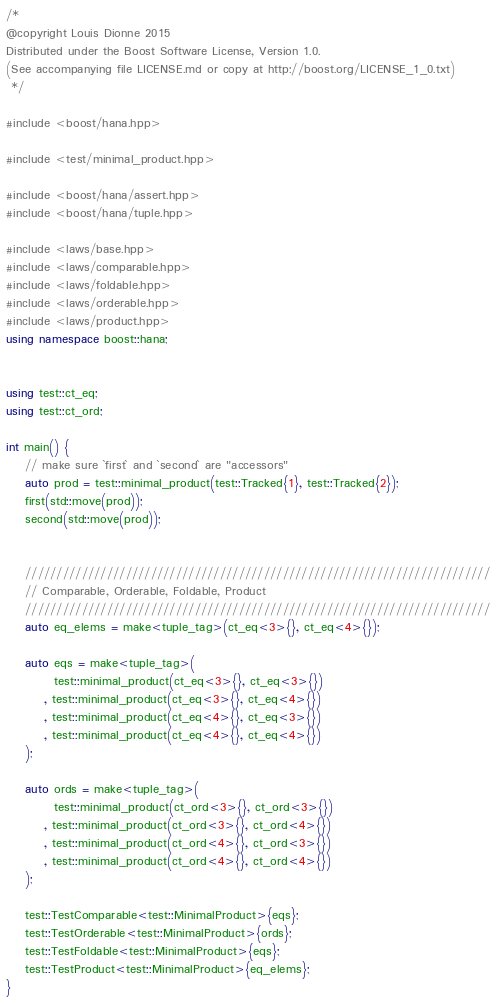Convert code to text. <code><loc_0><loc_0><loc_500><loc_500><_C++_>/*
@copyright Louis Dionne 2015
Distributed under the Boost Software License, Version 1.0.
(See accompanying file LICENSE.md or copy at http://boost.org/LICENSE_1_0.txt)
 */

#include <boost/hana.hpp>

#include <test/minimal_product.hpp>

#include <boost/hana/assert.hpp>
#include <boost/hana/tuple.hpp>

#include <laws/base.hpp>
#include <laws/comparable.hpp>
#include <laws/foldable.hpp>
#include <laws/orderable.hpp>
#include <laws/product.hpp>
using namespace boost::hana;


using test::ct_eq;
using test::ct_ord;

int main() {
    // make sure `first` and `second` are "accessors"
    auto prod = test::minimal_product(test::Tracked{1}, test::Tracked{2});
    first(std::move(prod));
    second(std::move(prod));


    //////////////////////////////////////////////////////////////////////////
    // Comparable, Orderable, Foldable, Product
    //////////////////////////////////////////////////////////////////////////
    auto eq_elems = make<tuple_tag>(ct_eq<3>{}, ct_eq<4>{});

    auto eqs = make<tuple_tag>(
          test::minimal_product(ct_eq<3>{}, ct_eq<3>{})
        , test::minimal_product(ct_eq<3>{}, ct_eq<4>{})
        , test::minimal_product(ct_eq<4>{}, ct_eq<3>{})
        , test::minimal_product(ct_eq<4>{}, ct_eq<4>{})
    );

    auto ords = make<tuple_tag>(
          test::minimal_product(ct_ord<3>{}, ct_ord<3>{})
        , test::minimal_product(ct_ord<3>{}, ct_ord<4>{})
        , test::minimal_product(ct_ord<4>{}, ct_ord<3>{})
        , test::minimal_product(ct_ord<4>{}, ct_ord<4>{})
    );

    test::TestComparable<test::MinimalProduct>{eqs};
    test::TestOrderable<test::MinimalProduct>{ords};
    test::TestFoldable<test::MinimalProduct>{eqs};
    test::TestProduct<test::MinimalProduct>{eq_elems};
}
</code> 